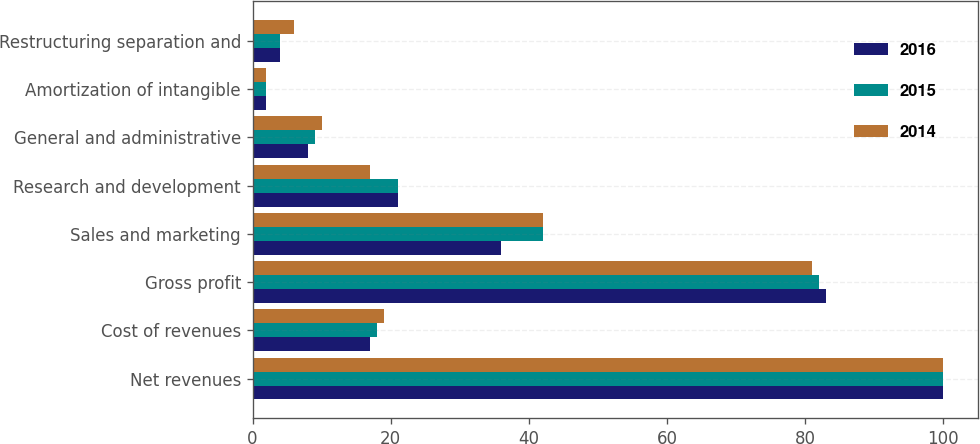Convert chart. <chart><loc_0><loc_0><loc_500><loc_500><stacked_bar_chart><ecel><fcel>Net revenues<fcel>Cost of revenues<fcel>Gross profit<fcel>Sales and marketing<fcel>Research and development<fcel>General and administrative<fcel>Amortization of intangible<fcel>Restructuring separation and<nl><fcel>2016<fcel>100<fcel>17<fcel>83<fcel>36<fcel>21<fcel>8<fcel>2<fcel>4<nl><fcel>2015<fcel>100<fcel>18<fcel>82<fcel>42<fcel>21<fcel>9<fcel>2<fcel>4<nl><fcel>2014<fcel>100<fcel>19<fcel>81<fcel>42<fcel>17<fcel>10<fcel>2<fcel>6<nl></chart> 